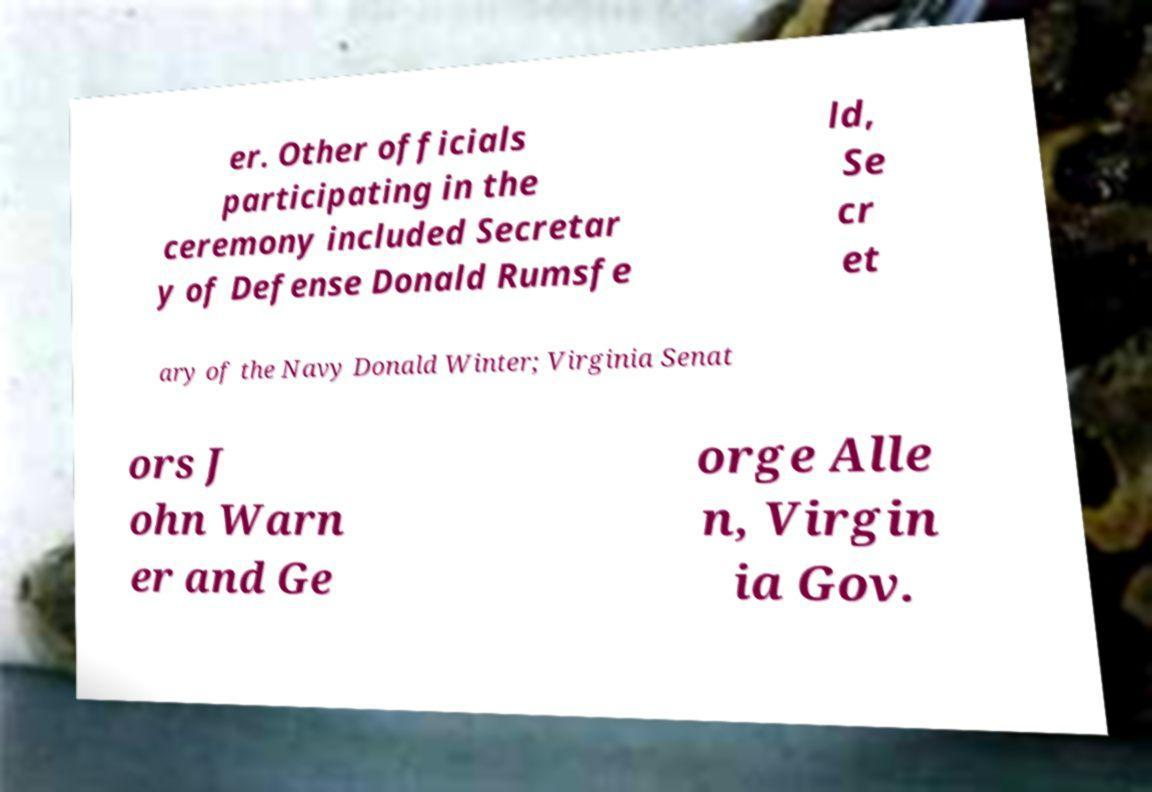Could you assist in decoding the text presented in this image and type it out clearly? er. Other officials participating in the ceremony included Secretar y of Defense Donald Rumsfe ld, Se cr et ary of the Navy Donald Winter; Virginia Senat ors J ohn Warn er and Ge orge Alle n, Virgin ia Gov. 